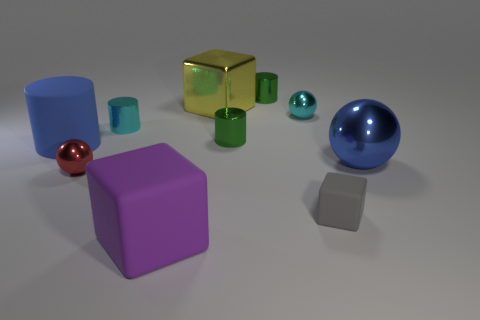What's the biggest object in the image? The biggest object in the image is the blue sphere. Its size is visually dominant compared to the other shapes present. What could the size difference imply if this were a symbolic representation? If this setup is symbolic, the size difference might imply that the blue sphere represents a concept with greater significance or influence than the other shapes, perhaps symbolizing a planet or a central entity in a system. 